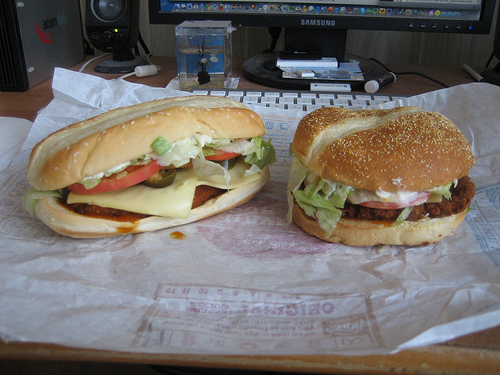How does the background environment complement the overall food image? The computer setup in the background adds a practical, everyday feel to the image. It suggests a casual meal break in a home or office setting, making the scene relatable and comfortingly familiar. Discuss the potential history behind the food wrappers seen in the image. The wrappers have a crinkled, well-used look, suggesting that these are takeout meals possibly enjoyed frequently. They might tell stories of quick lunches during work breaks, shared among colleagues or close friends, each meal bringing with it the familiarity and joy of a much-needed pause in the day's routine. Create a vivid narrative about an imaginary adventure where these burgers travel through different cuisines before being assembled. Once upon a time in the bustling market of flavors, a group of ingredients set out on a gourmet adventure. The ground beef traveled through the smoky streets of Kansas City, learning the fine art of barbeque seasoning. Meanwhile, the lettuce leaves, fresh from the valleys of California, danced with the crisp winds, developing a vibrant crunch. Tomato slices soaked in the sun-drenched fields of Italy, absorbing the rich, tangy heritage of Mediterranean cuisine. The provolone cheese traveled from the artisan dairies of Paris, gaining a smoky, creamy texture. These experienced travelers met at a rustic kitchen, where a master chef skillfully blended their unique stories into mouth-watering creations—hamburgers that spoke the universal language of taste. 